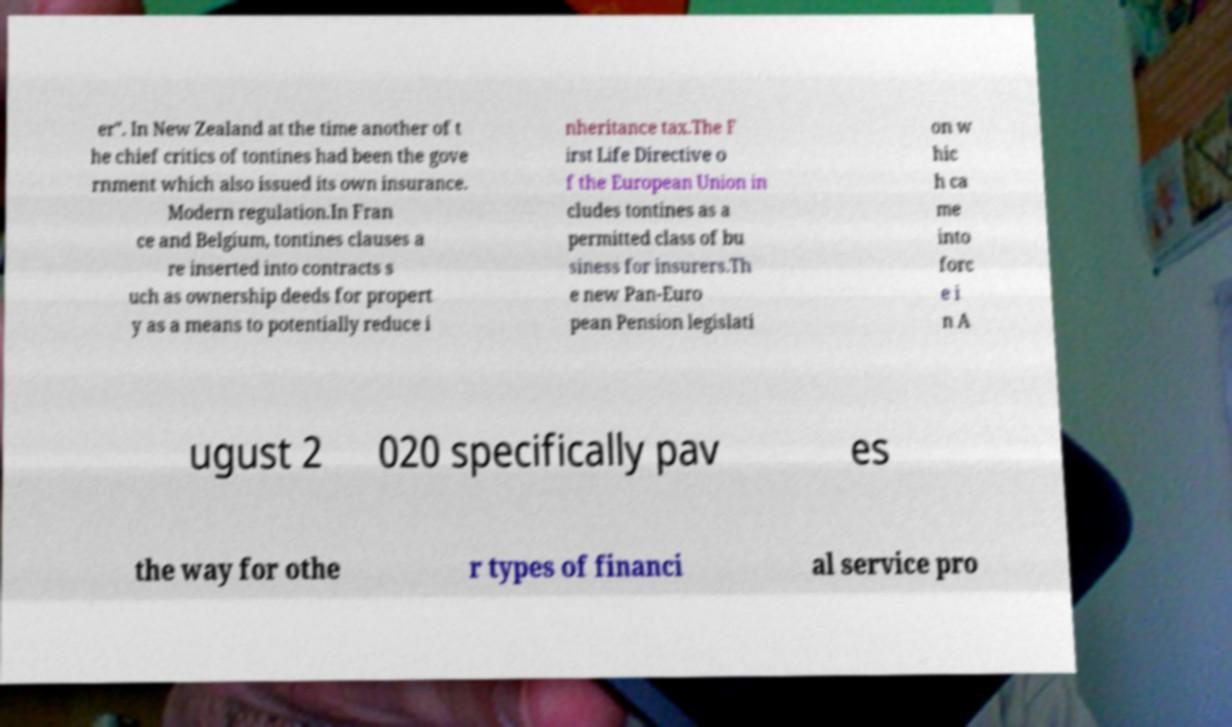What messages or text are displayed in this image? I need them in a readable, typed format. er". In New Zealand at the time another of t he chief critics of tontines had been the gove rnment which also issued its own insurance. Modern regulation.In Fran ce and Belgium, tontines clauses a re inserted into contracts s uch as ownership deeds for propert y as a means to potentially reduce i nheritance tax.The F irst Life Directive o f the European Union in cludes tontines as a permitted class of bu siness for insurers.Th e new Pan-Euro pean Pension legislati on w hic h ca me into forc e i n A ugust 2 020 specifically pav es the way for othe r types of financi al service pro 